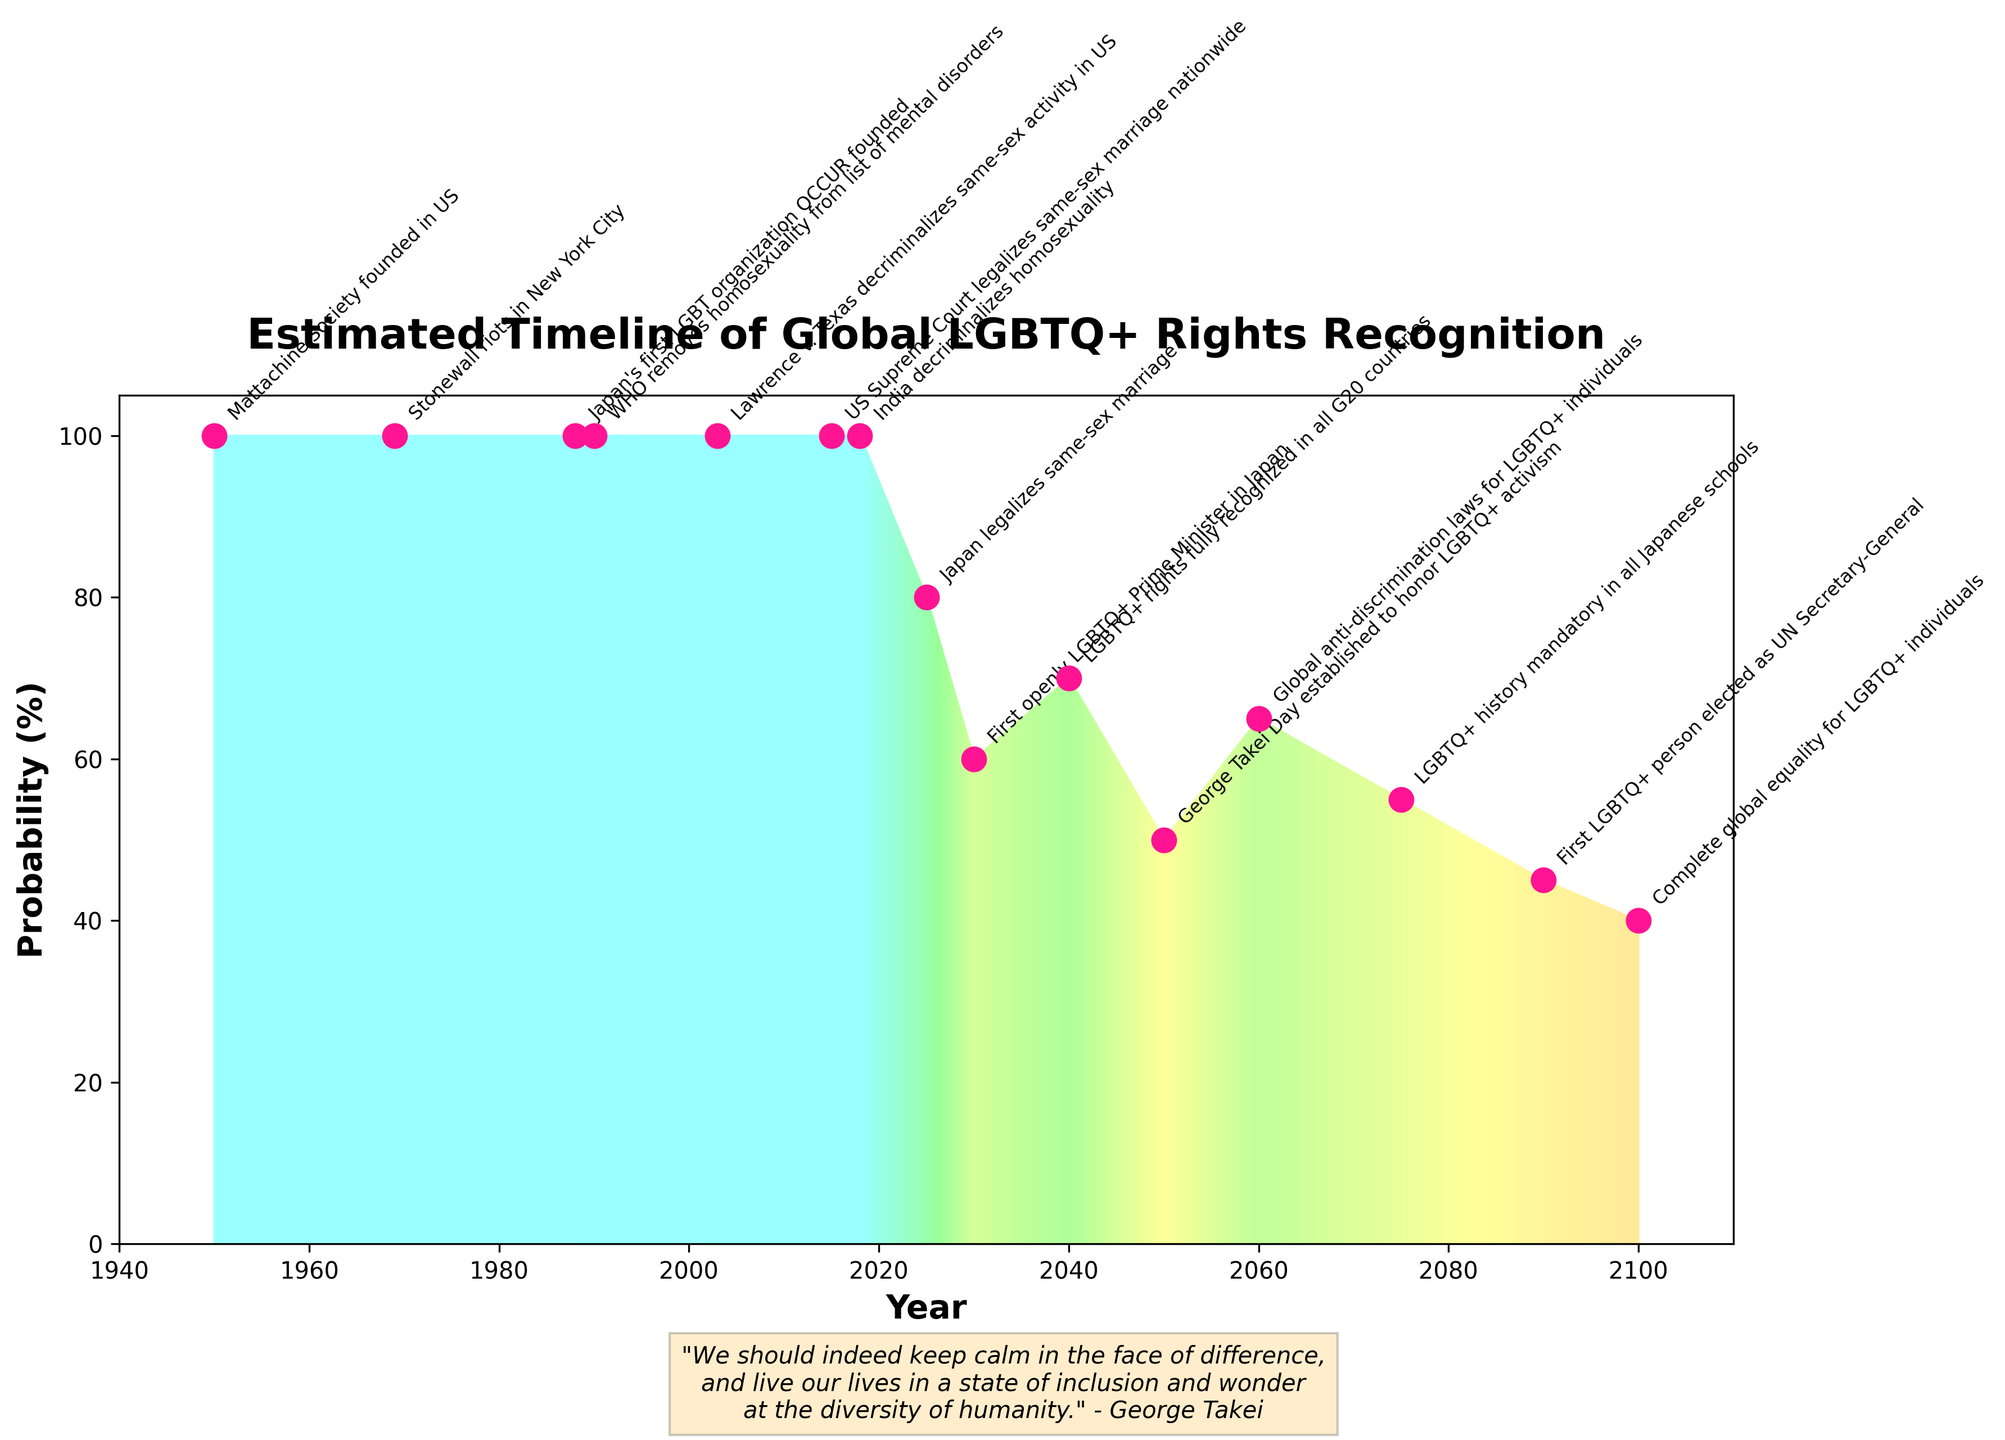What is the title of the chart? The title of the chart is displayed prominently at the top, indicating the main topic covered.
Answer: Estimated Timeline of Global LGBTQ+ Rights Recognition How many events are annotated in the fan chart? The number of annotated events is equal to the number of data points highlighted with labels in the chart.
Answer: 14 What does the fan chart suggest will happen in the year 2040? The fan chart depicts an event with annotations corresponding to the year 2040. The label specifies the expected event.
Answer: LGBTQ+ rights fully recognized in all G20 countries Compare the probability of Japan legalizing same-sex marriage in 2025 with the probability of the US Supreme Court legalizing same-sex marriage nationwide in 2015. Which has a higher probability? Identify the probability values for the specified events and compare them. The US Supreme Court event in 2015 has a probability of 100%, whereas Japan legalizing same-sex marriage in 2025 is at 80%.
Answer: US Supreme Court legalizing same-sex marriage nationwide What event is predicted with the lowest probability, and what year is it expected to occur? Locate the event with the lowest probability percentage and note the corresponding year. This can be found at the end of the chart where the probability values are marked.
Answer: Complete global equality for LGBTQ+ individuals in 2100 Calculate the average probability for the events between 1950 and 2018. Sum the probabilities of the events that occurred between 1950 and 2018, then divide by the number of events in this range. Calculated as (100 + 100 + 100 + 100 + 100 + 100 + 100) / 7 = 100%.
Answer: 100% What is the probability associated with the establishment of George Takei Day in 2050? Identify the annotated event along the year 2050 and read off its probability percentage from the chart.
Answer: 50% Is the recognition of LGBTQ+ rights in Japan predicted to occur before or after India decriminalizes homosexuality? Compare the years associated with these two events to determine their sequence. India decriminalized homosexuality in 2018, and Japan is predicted to legalize same-sex marriage in 2025, which is after.
Answer: After Which event in the chart signifies the first instance of a political milestone involving the LGBTQ+ community in Japan? Identify the event related to Japanese political milestones by noting the annotations and corresponding years. The first instance is Japan’s first LGBT organization OCCUR founded in 1988.
Answer: Japan's first LGBT organization OCCUR founded in 1988 What is the probability difference between the global anti-discrimination laws for LGBTQ+ individuals and the complete global equality for LGBTQ+ individuals? Subtract the probability value associated with global equality (40%) from the probability value for anti-discrimination laws (65%) for the difference. Calculation: 65% - 40% = 25%.
Answer: 25% 